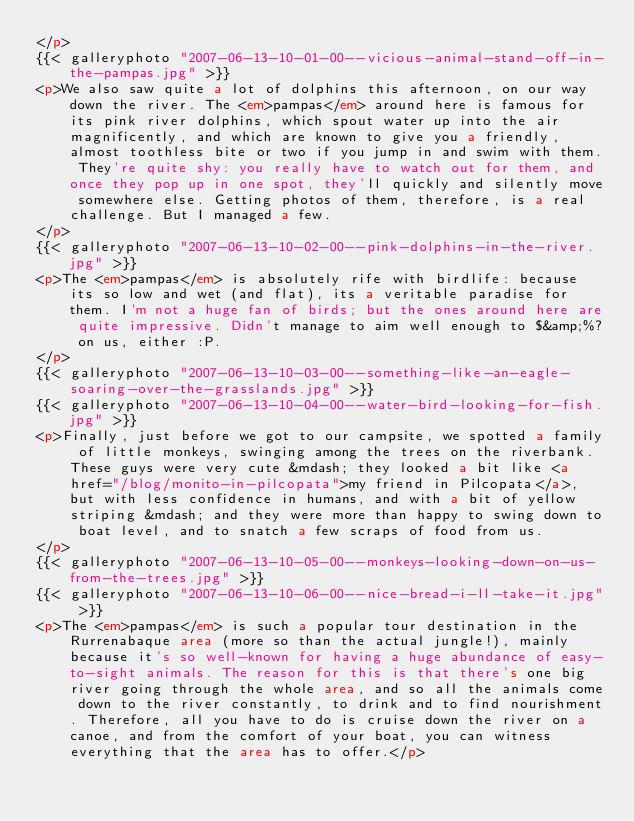Convert code to text. <code><loc_0><loc_0><loc_500><loc_500><_HTML_></p>
{{< galleryphoto "2007-06-13-10-01-00--vicious-animal-stand-off-in-the-pampas.jpg" >}}
<p>We also saw quite a lot of dolphins this afternoon, on our way down the river. The <em>pampas</em> around here is famous for its pink river dolphins, which spout water up into the air magnificently, and which are known to give you a friendly, almost toothless bite or two if you jump in and swim with them. They're quite shy: you really have to watch out for them, and once they pop up in one spot, they'll quickly and silently move somewhere else. Getting photos of them, therefore, is a real challenge. But I managed a few.
</p>
{{< galleryphoto "2007-06-13-10-02-00--pink-dolphins-in-the-river.jpg" >}}
<p>The <em>pampas</em> is absolutely rife with birdlife: because its so low and wet (and flat), its a veritable paradise for them. I'm not a huge fan of birds; but the ones around here are quite impressive. Didn't manage to aim well enough to $&amp;%? on us, either :P.
</p>
{{< galleryphoto "2007-06-13-10-03-00--something-like-an-eagle-soaring-over-the-grasslands.jpg" >}}
{{< galleryphoto "2007-06-13-10-04-00--water-bird-looking-for-fish.jpg" >}}
<p>Finally, just before we got to our campsite, we spotted a family of little monkeys, swinging among the trees on the riverbank. These guys were very cute &mdash; they looked a bit like <a href="/blog/monito-in-pilcopata">my friend in Pilcopata</a>, but with less confidence in humans, and with a bit of yellow striping &mdash; and they were more than happy to swing down to boat level, and to snatch a few scraps of food from us.
</p>
{{< galleryphoto "2007-06-13-10-05-00--monkeys-looking-down-on-us-from-the-trees.jpg" >}}
{{< galleryphoto "2007-06-13-10-06-00--nice-bread-i-ll-take-it.jpg" >}}
<p>The <em>pampas</em> is such a popular tour destination in the Rurrenabaque area (more so than the actual jungle!), mainly because it's so well-known for having a huge abundance of easy-to-sight animals. The reason for this is that there's one big river going through the whole area, and so all the animals come down to the river constantly, to drink and to find nourishment. Therefore, all you have to do is cruise down the river on a canoe, and from the comfort of your boat, you can witness everything that the area has to offer.</p>
</code> 